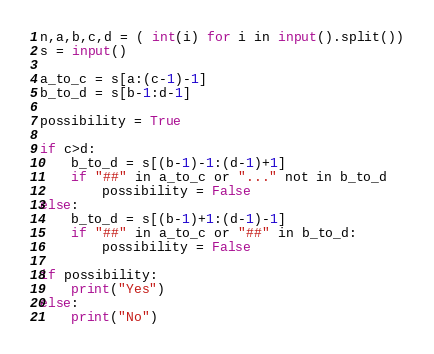<code> <loc_0><loc_0><loc_500><loc_500><_Python_>n,a,b,c,d = ( int(i) for i in input().split())
s = input()

a_to_c = s[a:(c-1)-1]
b_to_d = s[b-1:d-1]

possibility = True

if c>d:
    b_to_d = s[(b-1)-1:(d-1)+1]
    if "##" in a_to_c or "..." not in b_to_d
        possibility = False
else:
    b_to_d = s[(b-1)+1:(d-1)-1]
    if "##" in a_to_c or "##" in b_to_d:
        possibility = False

if possibility:
    print("Yes")
else:
    print("No")</code> 